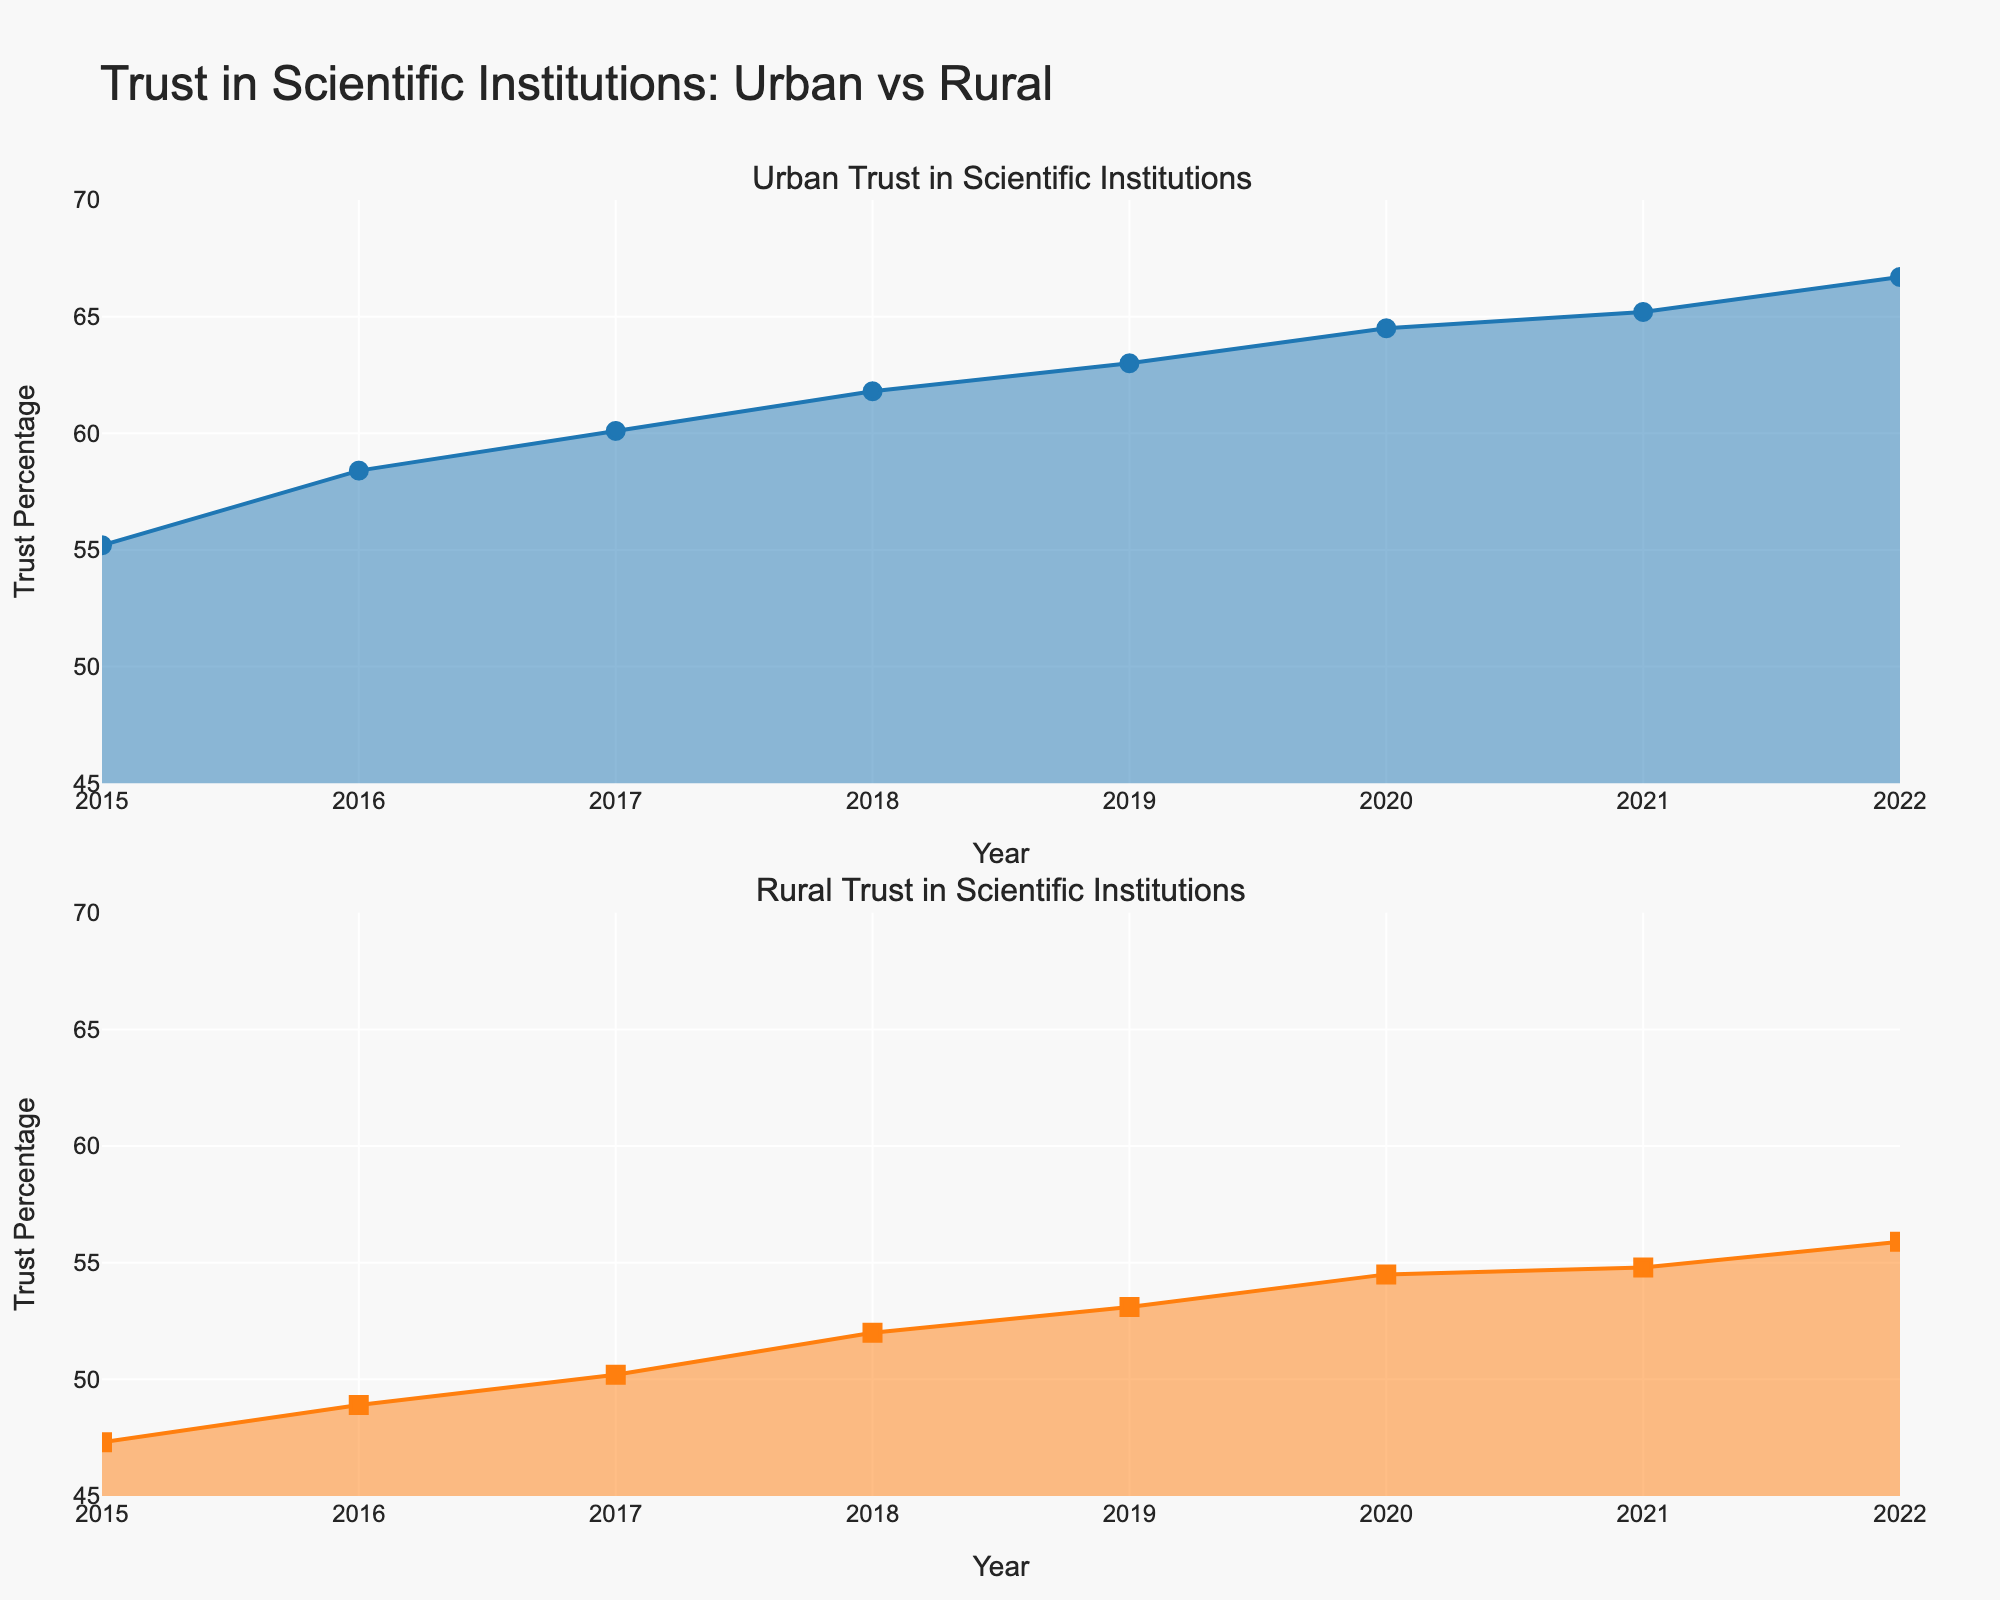What's the title of the figure? The title of the figure is usually found at the top of the plot. In this case, it states "Trust in Scientific Institutions: Urban vs Rural."
Answer: Trust in Scientific Institutions: Urban vs Rural What is the y-axis title in each subplot? The y-axis title can be seen on the left axis of each subplot. Both subplots have the title "Trust Percentage."
Answer: Trust Percentage What is the range of years displayed in the figure? The years are displayed along the x-axis of both subplots. They range from 2015 to 2022.
Answer: 2015 to 2022 Which group showed a higher trust percentage in 2020? By observing the values of trust percentages for 2020 in both subplots, we can see that the Urban group has a higher trust percentage than the Rural group.
Answer: Urban What is the difference in trust percentage between Urban and Rural in 2022? The trust percentage for Urban in 2022 is 66.7, and for Rural, it is 55.9. Subtracting the Rural value from the Urban value gives the difference: 66.7 - 55.9 = 10.8.
Answer: 10.8 How much did the trust percentage increase for the Rural group from 2015 to 2022? The trust percentage for the Rural group in 2015 is 47.3, and in 2022, it is 55.9. The increase is calculated as 55.9 - 47.3 = 8.6.
Answer: 8.6 Which group had a more significant increase in trust percentage from 2015 to 2022? Compare the increase for both groups: Urban increased from 55.2 to 66.7 (an increase of 66.7 - 55.2 = 11.5), while Rural increased from 47.3 to 55.9 (an increase of 55.9 - 47.3 = 8.6). So, the Urban group had a more significant increase.
Answer: Urban What is the average trust percentage for the Urban group over the years? To find the average, add up all the yearly percentages for the Urban group (55.2 + 58.4 + 60.1 + 61.8 + 63.0 + 64.5 + 65.2 + 66.7) and divide by the number of years (8). The sum is 495.9, and the average is 495.9 / 8 = 61.9875.
Answer: 61.99 During which year did the Rural group experience the highest increase in trust percentage? By inspecting the changes year by year for the Rural group: 2015-2016 (47.3 to 48.9, +1.6), 2016-2017 (48.9 to 50.2, +1.3), 2017-2018 (50.2 to 52.0, +1.8), 2018-2019 (52.0 to 53.1, +1.1), 2019-2020 (53.1 to 54.5, +1.4), 2020-2021 (54.5 to 54.8, +0.3), and 2021-2022 (54.8 to 55.9, +1.1). The highest increase is from 2017 to 2018 (+1.8).
Answer: 2017-2018 